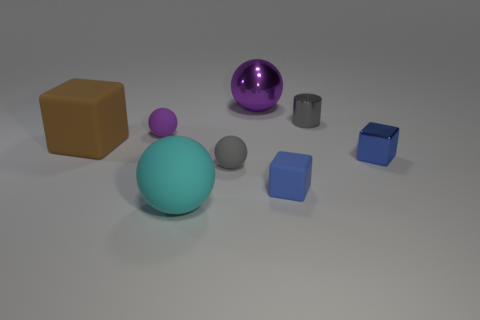Is the number of blue cubes that are behind the tiny blue shiny thing the same as the number of big purple shiny objects to the right of the big brown thing? No, the numbers are not the same. There is one blue cube behind the tiny blue shiny sphere, whereas there are no big purple shiny objects to the right of the big brown cube. The scene comprises a variety of objects with different sizes, colors, and shapes, allowing for a multitude of such comparative observations. 